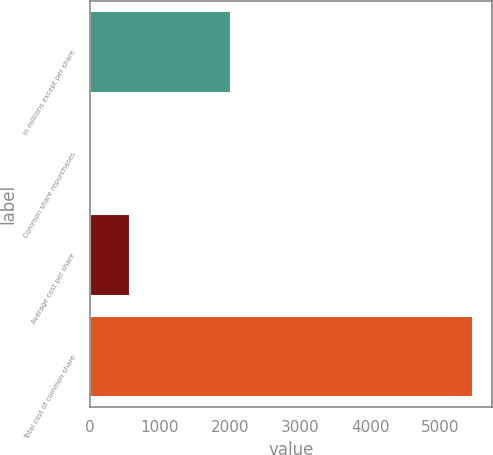Convert chart. <chart><loc_0><loc_0><loc_500><loc_500><bar_chart><fcel>in millions except per share<fcel>Common share repurchases<fcel>Average cost per share<fcel>Total cost of common share<nl><fcel>2014<fcel>31.8<fcel>575.52<fcel>5469<nl></chart> 